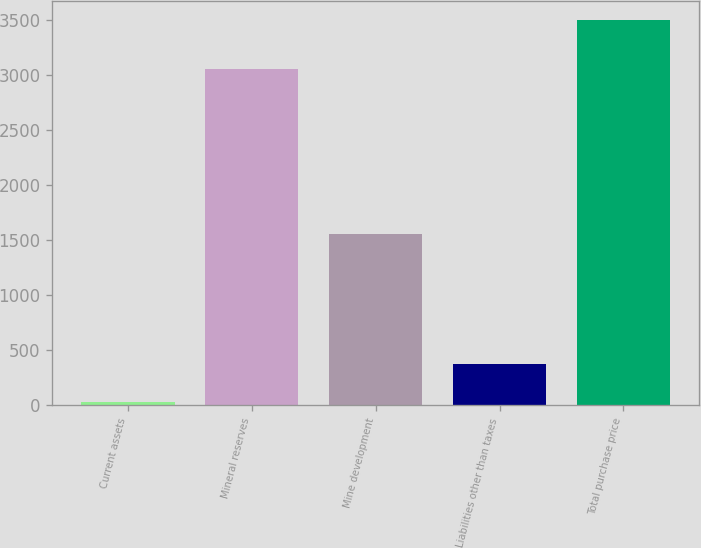<chart> <loc_0><loc_0><loc_500><loc_500><bar_chart><fcel>Current assets<fcel>Mineral reserves<fcel>Mine development<fcel>Liabilities other than taxes<fcel>Total purchase price<nl><fcel>25<fcel>3056<fcel>1559<fcel>372.5<fcel>3500<nl></chart> 